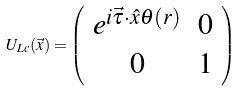<formula> <loc_0><loc_0><loc_500><loc_500>U _ { L c } ( \vec { x } ) = \left ( \begin{array} { c c } e ^ { i \vec { \tau } \cdot \hat { x } \theta ( r ) } & 0 \\ 0 & 1 \end{array} \right )</formula> 